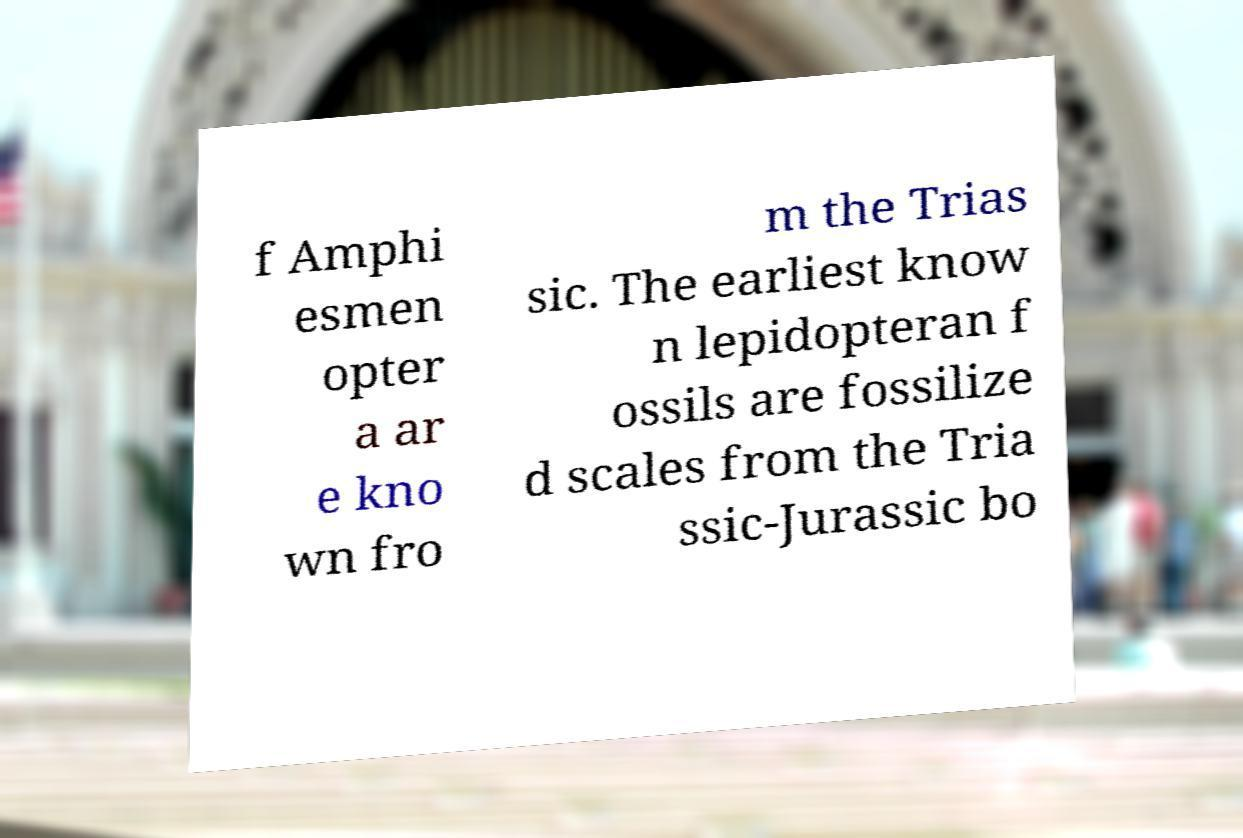Please identify and transcribe the text found in this image. f Amphi esmen opter a ar e kno wn fro m the Trias sic. The earliest know n lepidopteran f ossils are fossilize d scales from the Tria ssic-Jurassic bo 